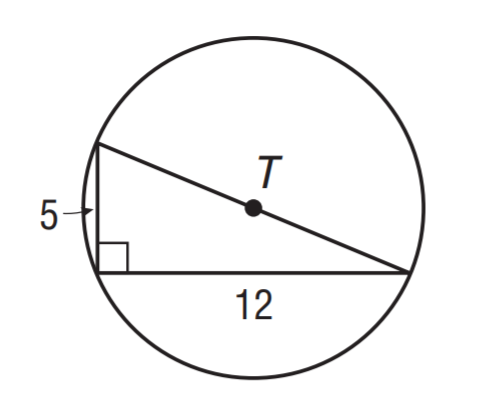Answer the mathemtical geometry problem and directly provide the correct option letter.
Question: What is the circumference of \odot T? Round to the nearest tenth.
Choices: A: 37.2 B: 39.6 C: 40.8 D: 42.4 C 